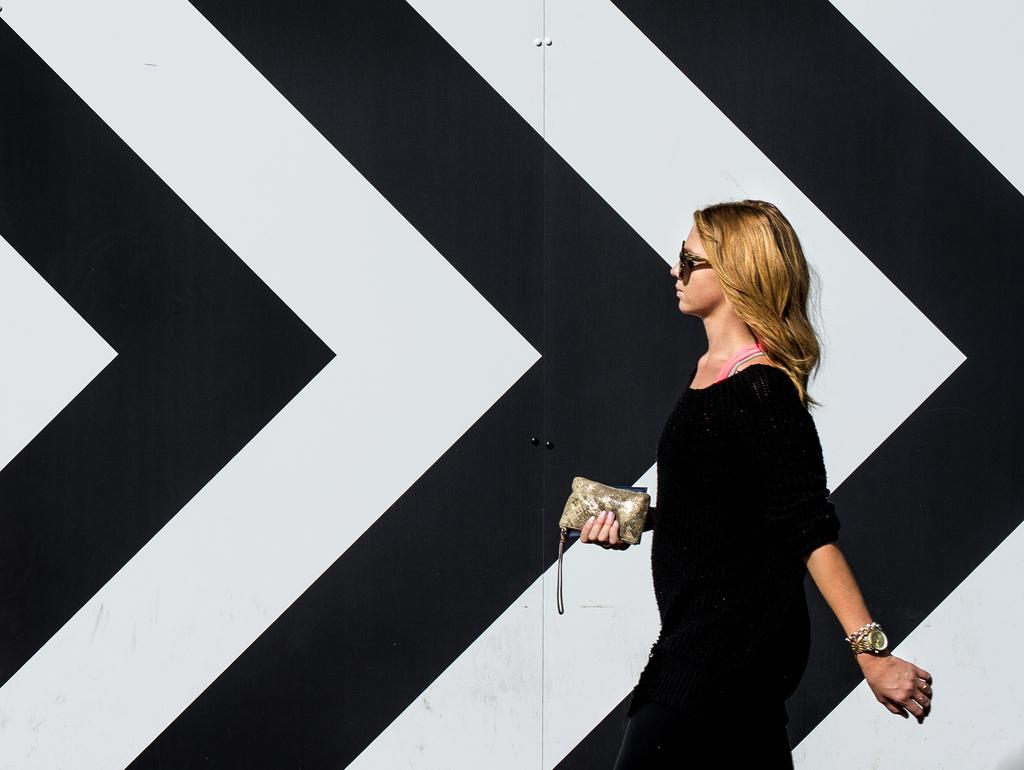Who is present in the image? There is a woman in the image. What is the woman holding in the image? The woman is holding a clutch. What type of eyewear is the woman wearing? The woman is wearing goggles. What can be seen in the background of the image? There are white and black arrows in the background of the image. What type of stove can be seen in the image? There is no stove present in the image. What authority figure is depicted in the image? There is no authority figure depicted in the image. 